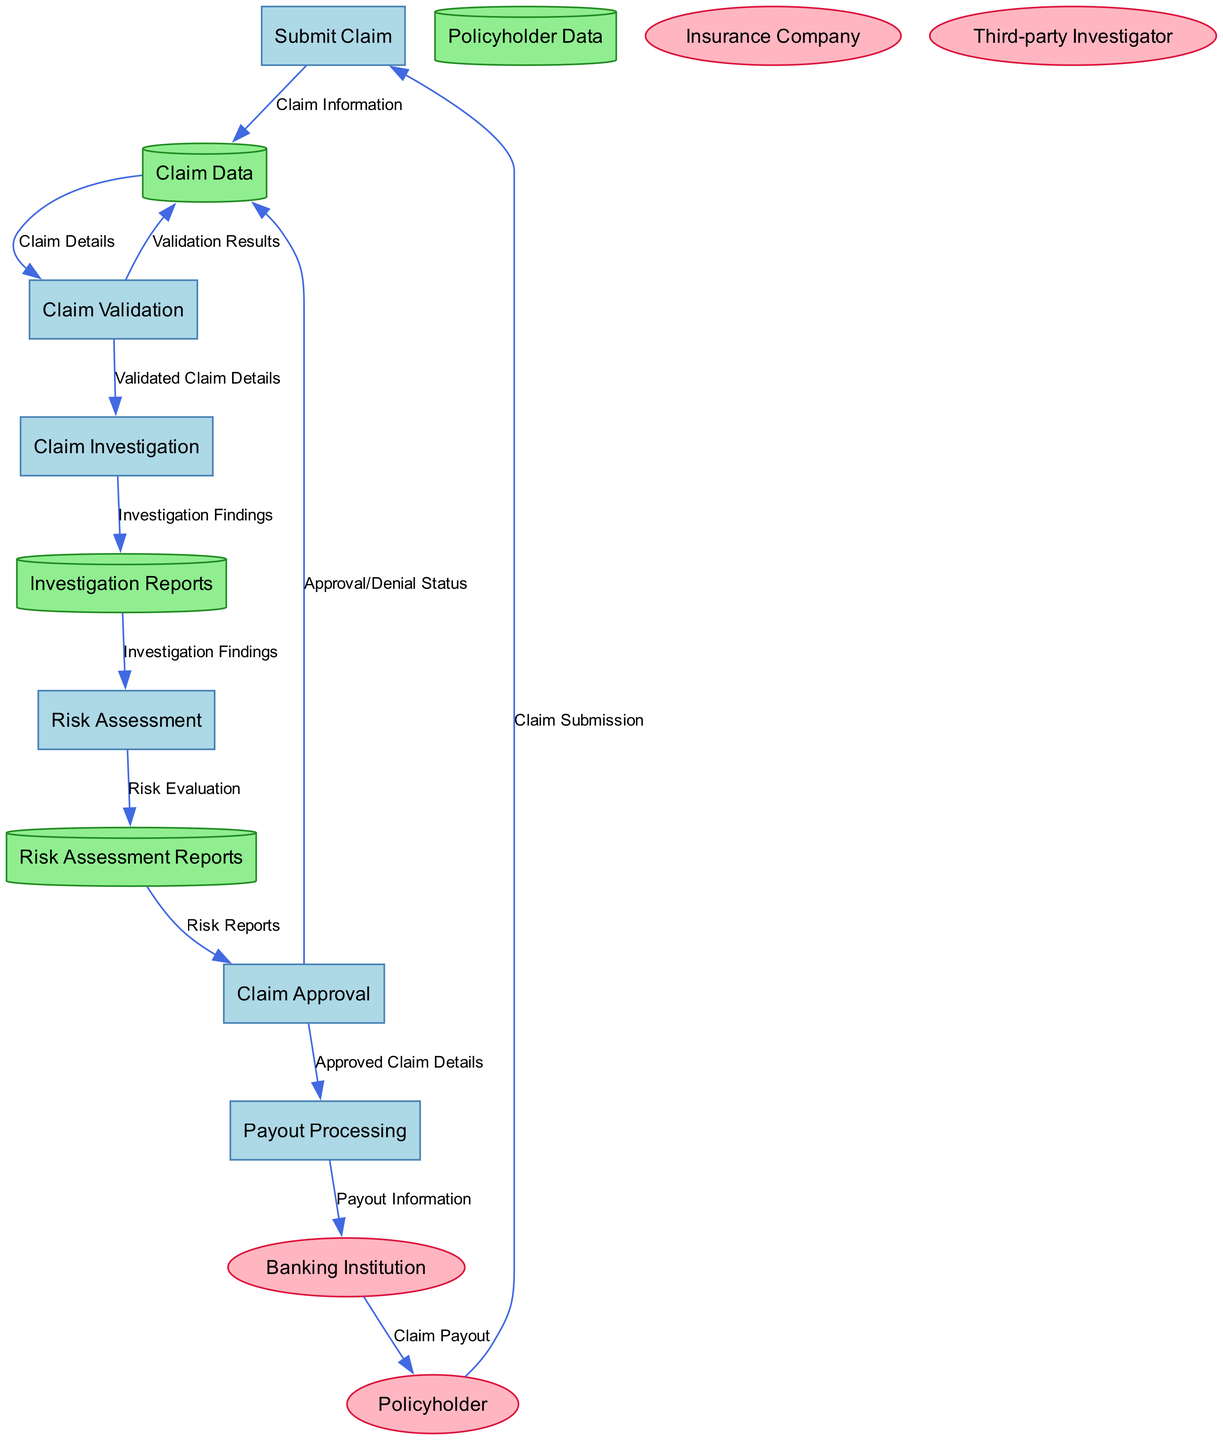What is the first process in the claims handling flow? The first process in the diagram is indicated as "Submit Claim." It is the initial step that starts the claims handling process for construction-related insurance.
Answer: Submit Claim How many data stores are present in the diagram? The diagram lists four data stores: Policyholder Data, Claim Data, Investigation Reports, and Risk Assessment Reports. Counting these provides the total number of data stores.
Answer: Four What type of entity is "Banking Institution"? The diagram categorizes "Banking Institution" as an external entity, as it interacts with the claims process but is not an internal part of the insurance processing system.
Answer: External Entity Which process comes after "Claim Validation"? The process that follows "Claim Validation" in the flow is "Claim Investigation." The arrows connecting the processes indicate the order of operations.
Answer: Claim Investigation What data flows from "Claim Approval" to "Claim Data"? The data that flows from "Claim Approval" to "Claim Data" is referred to as "Approval/Denial Status." This indicates the outcome of the claim's approval process.
Answer: Approval/Denial Status Which node receives data from "Claim Investigation"? The node that receives data from "Claim Investigation" is "Investigation Reports." This relationship signifies that the findings from the investigation are documented in that data store.
Answer: Investigation Reports What is the output of "Payout Processing"? The output of "Payout Processing" is sent to "Banking Institution," and it consists of payout information to process the financial transaction of the claim payout.
Answer: Payout Information How many processes are involved in the claims handling process? There are six processes listed in the diagram: Submit Claim, Claim Validation, Claim Investigation, Risk Assessment, Claim Approval, and Payout Processing. Counting these gives the total.
Answer: Six What type of data flows from "Risk Assessment" to "Risk Assessment Reports"? The type of data flowing from "Risk Assessment" to "Risk Assessment Reports" is termed as "Risk Evaluation." This flow indicates that the evaluation outcomes are stored in that data store.
Answer: Risk Evaluation 